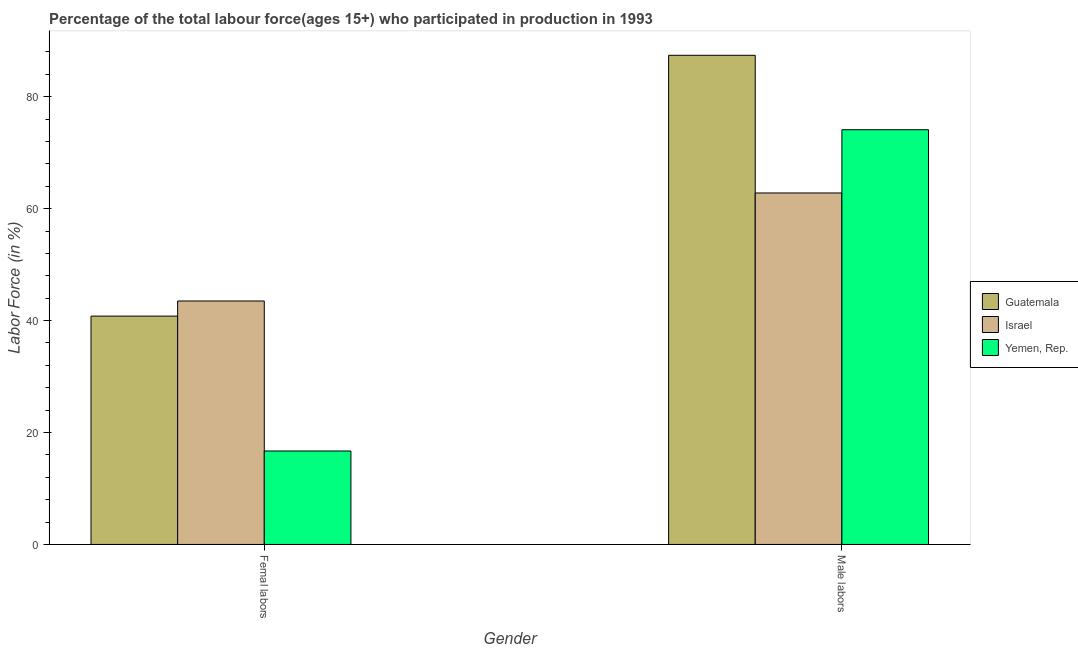How many groups of bars are there?
Your answer should be very brief. 2. Are the number of bars on each tick of the X-axis equal?
Ensure brevity in your answer.  Yes. How many bars are there on the 2nd tick from the left?
Offer a terse response. 3. What is the label of the 2nd group of bars from the left?
Your answer should be compact. Male labors. What is the percentage of male labour force in Israel?
Offer a very short reply. 62.8. Across all countries, what is the maximum percentage of female labor force?
Provide a short and direct response. 43.5. Across all countries, what is the minimum percentage of female labor force?
Offer a very short reply. 16.7. In which country was the percentage of male labour force maximum?
Offer a terse response. Guatemala. In which country was the percentage of male labour force minimum?
Your answer should be compact. Israel. What is the total percentage of female labor force in the graph?
Provide a succinct answer. 101. What is the difference between the percentage of female labor force in Yemen, Rep. and that in Israel?
Ensure brevity in your answer.  -26.8. What is the difference between the percentage of female labor force in Israel and the percentage of male labour force in Guatemala?
Give a very brief answer. -43.9. What is the average percentage of male labour force per country?
Provide a succinct answer. 74.77. What is the difference between the percentage of male labour force and percentage of female labor force in Guatemala?
Offer a very short reply. 46.6. In how many countries, is the percentage of female labor force greater than 28 %?
Your answer should be very brief. 2. What is the ratio of the percentage of male labour force in Guatemala to that in Israel?
Keep it short and to the point. 1.39. In how many countries, is the percentage of female labor force greater than the average percentage of female labor force taken over all countries?
Your answer should be very brief. 2. What does the 1st bar from the left in Femal labors represents?
Ensure brevity in your answer.  Guatemala. What does the 2nd bar from the right in Male labors represents?
Keep it short and to the point. Israel. Are the values on the major ticks of Y-axis written in scientific E-notation?
Provide a short and direct response. No. Does the graph contain any zero values?
Keep it short and to the point. No. How many legend labels are there?
Your answer should be very brief. 3. What is the title of the graph?
Offer a terse response. Percentage of the total labour force(ages 15+) who participated in production in 1993. What is the label or title of the Y-axis?
Offer a terse response. Labor Force (in %). What is the Labor Force (in %) in Guatemala in Femal labors?
Your answer should be very brief. 40.8. What is the Labor Force (in %) in Israel in Femal labors?
Your answer should be very brief. 43.5. What is the Labor Force (in %) in Yemen, Rep. in Femal labors?
Offer a terse response. 16.7. What is the Labor Force (in %) of Guatemala in Male labors?
Give a very brief answer. 87.4. What is the Labor Force (in %) in Israel in Male labors?
Provide a short and direct response. 62.8. What is the Labor Force (in %) of Yemen, Rep. in Male labors?
Provide a short and direct response. 74.1. Across all Gender, what is the maximum Labor Force (in %) of Guatemala?
Keep it short and to the point. 87.4. Across all Gender, what is the maximum Labor Force (in %) of Israel?
Give a very brief answer. 62.8. Across all Gender, what is the maximum Labor Force (in %) of Yemen, Rep.?
Provide a succinct answer. 74.1. Across all Gender, what is the minimum Labor Force (in %) in Guatemala?
Your response must be concise. 40.8. Across all Gender, what is the minimum Labor Force (in %) in Israel?
Keep it short and to the point. 43.5. Across all Gender, what is the minimum Labor Force (in %) in Yemen, Rep.?
Your answer should be compact. 16.7. What is the total Labor Force (in %) in Guatemala in the graph?
Give a very brief answer. 128.2. What is the total Labor Force (in %) of Israel in the graph?
Keep it short and to the point. 106.3. What is the total Labor Force (in %) in Yemen, Rep. in the graph?
Your response must be concise. 90.8. What is the difference between the Labor Force (in %) in Guatemala in Femal labors and that in Male labors?
Your answer should be very brief. -46.6. What is the difference between the Labor Force (in %) of Israel in Femal labors and that in Male labors?
Make the answer very short. -19.3. What is the difference between the Labor Force (in %) of Yemen, Rep. in Femal labors and that in Male labors?
Your answer should be very brief. -57.4. What is the difference between the Labor Force (in %) in Guatemala in Femal labors and the Labor Force (in %) in Yemen, Rep. in Male labors?
Ensure brevity in your answer.  -33.3. What is the difference between the Labor Force (in %) in Israel in Femal labors and the Labor Force (in %) in Yemen, Rep. in Male labors?
Keep it short and to the point. -30.6. What is the average Labor Force (in %) in Guatemala per Gender?
Offer a terse response. 64.1. What is the average Labor Force (in %) of Israel per Gender?
Offer a terse response. 53.15. What is the average Labor Force (in %) in Yemen, Rep. per Gender?
Keep it short and to the point. 45.4. What is the difference between the Labor Force (in %) in Guatemala and Labor Force (in %) in Israel in Femal labors?
Give a very brief answer. -2.7. What is the difference between the Labor Force (in %) in Guatemala and Labor Force (in %) in Yemen, Rep. in Femal labors?
Your answer should be very brief. 24.1. What is the difference between the Labor Force (in %) in Israel and Labor Force (in %) in Yemen, Rep. in Femal labors?
Provide a short and direct response. 26.8. What is the difference between the Labor Force (in %) of Guatemala and Labor Force (in %) of Israel in Male labors?
Your answer should be very brief. 24.6. What is the difference between the Labor Force (in %) of Israel and Labor Force (in %) of Yemen, Rep. in Male labors?
Your response must be concise. -11.3. What is the ratio of the Labor Force (in %) of Guatemala in Femal labors to that in Male labors?
Offer a terse response. 0.47. What is the ratio of the Labor Force (in %) in Israel in Femal labors to that in Male labors?
Make the answer very short. 0.69. What is the ratio of the Labor Force (in %) of Yemen, Rep. in Femal labors to that in Male labors?
Your answer should be very brief. 0.23. What is the difference between the highest and the second highest Labor Force (in %) of Guatemala?
Provide a succinct answer. 46.6. What is the difference between the highest and the second highest Labor Force (in %) of Israel?
Your answer should be very brief. 19.3. What is the difference between the highest and the second highest Labor Force (in %) in Yemen, Rep.?
Keep it short and to the point. 57.4. What is the difference between the highest and the lowest Labor Force (in %) of Guatemala?
Offer a very short reply. 46.6. What is the difference between the highest and the lowest Labor Force (in %) of Israel?
Your answer should be very brief. 19.3. What is the difference between the highest and the lowest Labor Force (in %) in Yemen, Rep.?
Offer a terse response. 57.4. 